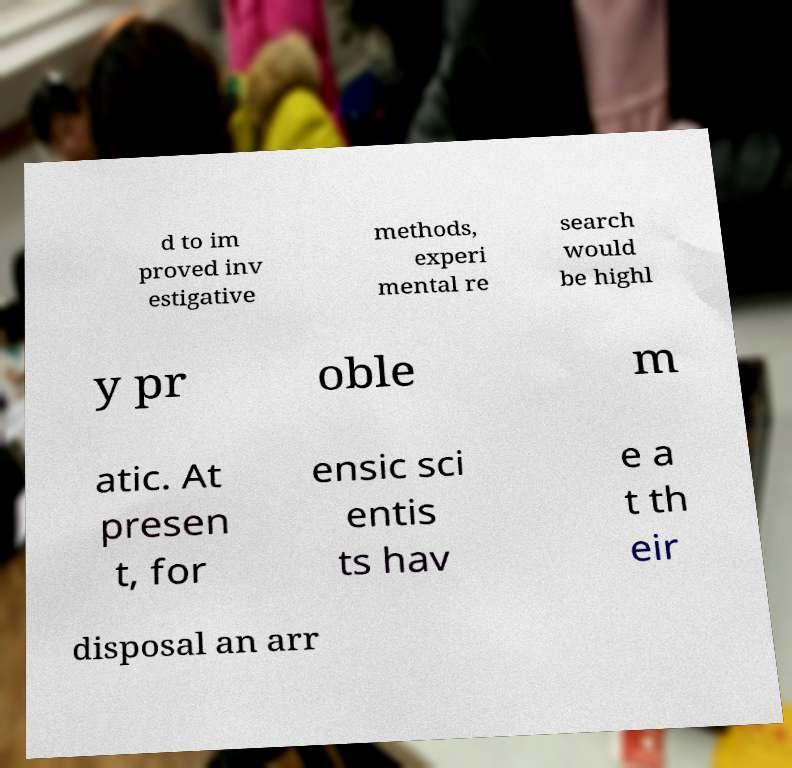Please identify and transcribe the text found in this image. d to im proved inv estigative methods, experi mental re search would be highl y pr oble m atic. At presen t, for ensic sci entis ts hav e a t th eir disposal an arr 